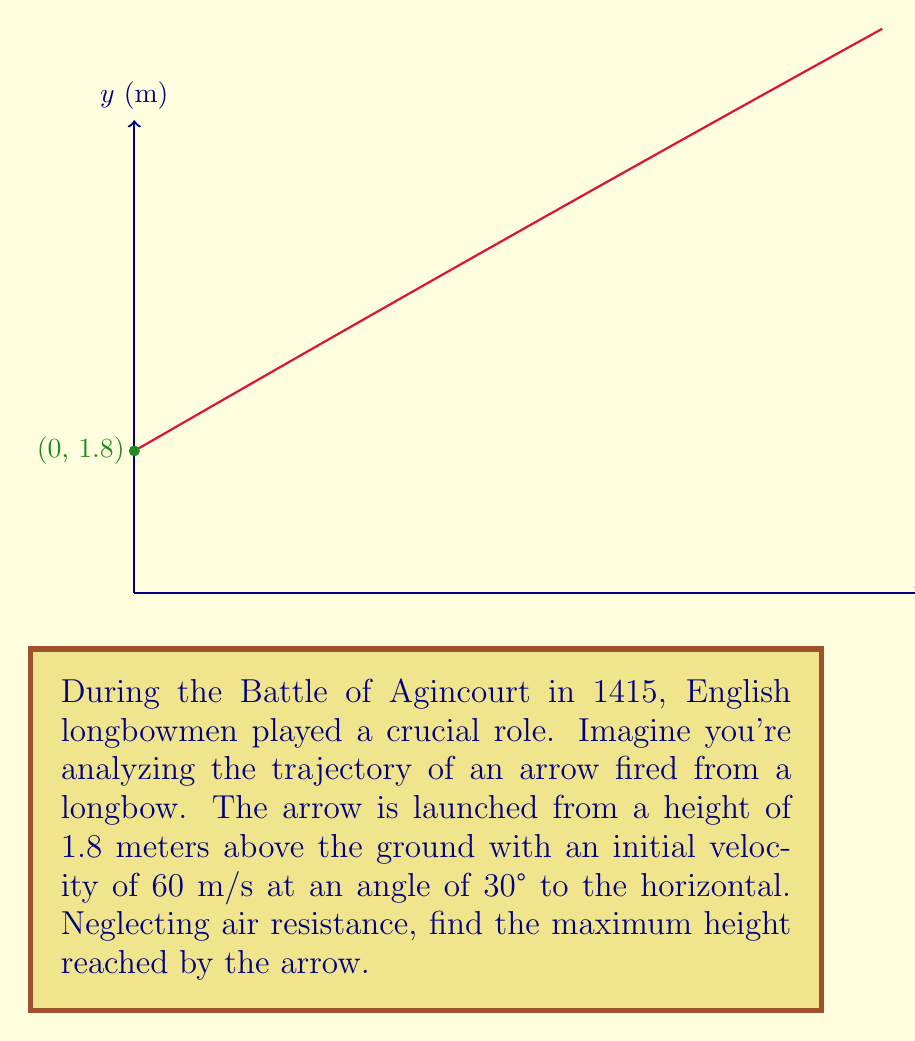Solve this math problem. Let's approach this step-by-step using a second-order linear equation:

1) The general equation for the trajectory of a projectile is:

   $$y = -\frac{g}{2v_0^2\cos^2\theta}x^2 + (x\tan\theta) + y_0$$

   Where $g$ is acceleration due to gravity (9.8 m/s²), $v_0$ is initial velocity, $\theta$ is launch angle, and $y_0$ is initial height.

2) Substituting our values:
   $v_0 = 60$ m/s
   $\theta = 30°$
   $y_0 = 1.8$ m

3) Our equation becomes:

   $$y = -\frac{9.8}{2(60^2\cos^230°)}x^2 + (x\tan30°) + 1.8$$

4) Simplify:
   $$y = -\frac{4.9}{3600}x^2 + \frac{x}{\sqrt{3}} + 1.8$$

5) To find the maximum height, we need to find where $\frac{dy}{dx} = 0$:

   $$\frac{dy}{dx} = -\frac{4.9}{1800}x + \frac{1}{\sqrt{3}}$$

6) Set this equal to zero and solve for x:

   $$-\frac{4.9}{1800}x + \frac{1}{\sqrt{3}} = 0$$
   $$x = \frac{1800}{\sqrt{3}(4.9)} \approx 211.8$$

7) Plug this x-value back into our original equation to find the maximum height:

   $$y = -\frac{4.9}{3600}(211.8)^2 + \frac{211.8}{\sqrt{3}} + 1.8 \approx 45.9$$

Therefore, the maximum height reached by the arrow is approximately 45.9 meters.
Answer: 45.9 meters 